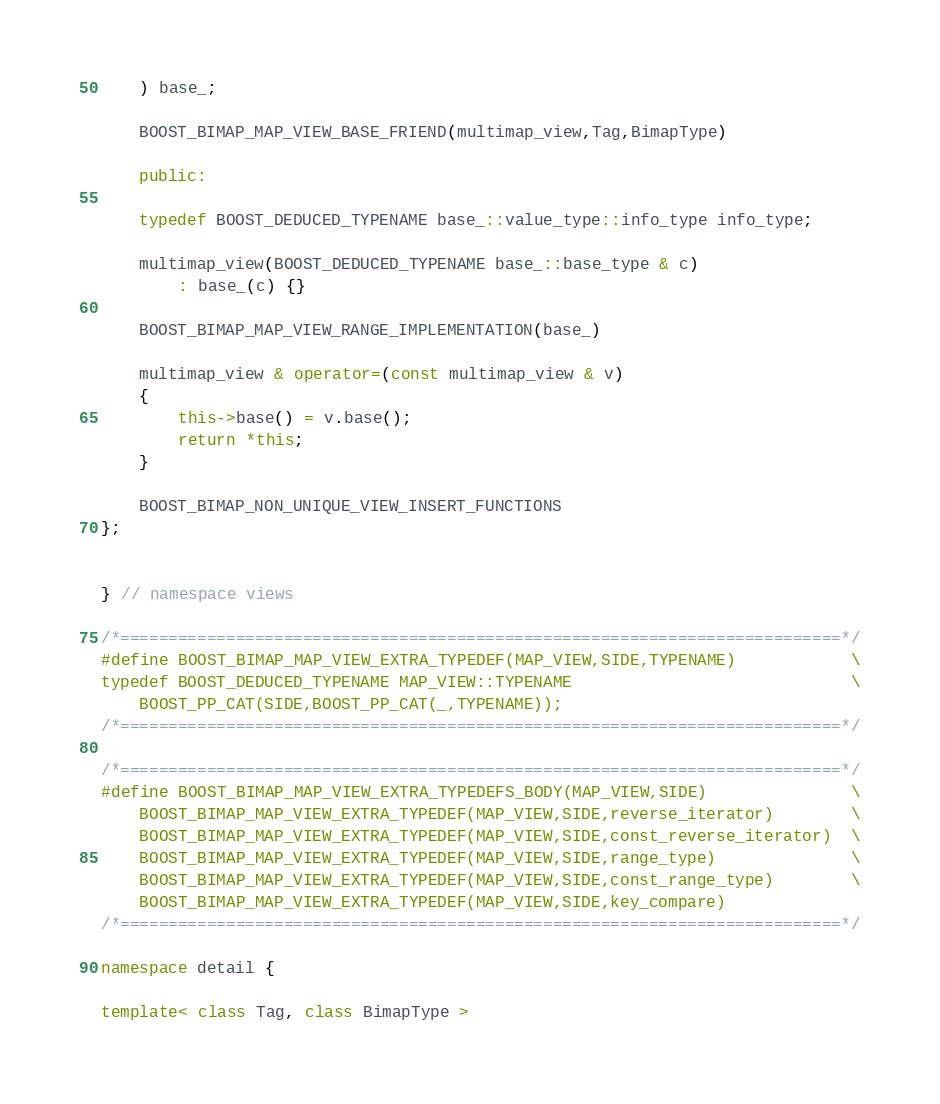Convert code to text. <code><loc_0><loc_0><loc_500><loc_500><_C++_>    ) base_;

    BOOST_BIMAP_MAP_VIEW_BASE_FRIEND(multimap_view,Tag,BimapType)

    public:

    typedef BOOST_DEDUCED_TYPENAME base_::value_type::info_type info_type;

    multimap_view(BOOST_DEDUCED_TYPENAME base_::base_type & c)
        : base_(c) {}

    BOOST_BIMAP_MAP_VIEW_RANGE_IMPLEMENTATION(base_)

    multimap_view & operator=(const multimap_view & v) 
    {
        this->base() = v.base();
        return *this;
    }

    BOOST_BIMAP_NON_UNIQUE_VIEW_INSERT_FUNCTIONS
};


} // namespace views

/*===========================================================================*/
#define BOOST_BIMAP_MAP_VIEW_EXTRA_TYPEDEF(MAP_VIEW,SIDE,TYPENAME)            \
typedef BOOST_DEDUCED_TYPENAME MAP_VIEW::TYPENAME                             \
    BOOST_PP_CAT(SIDE,BOOST_PP_CAT(_,TYPENAME));
/*===========================================================================*/

/*===========================================================================*/
#define BOOST_BIMAP_MAP_VIEW_EXTRA_TYPEDEFS_BODY(MAP_VIEW,SIDE)               \
    BOOST_BIMAP_MAP_VIEW_EXTRA_TYPEDEF(MAP_VIEW,SIDE,reverse_iterator)        \
    BOOST_BIMAP_MAP_VIEW_EXTRA_TYPEDEF(MAP_VIEW,SIDE,const_reverse_iterator)  \
    BOOST_BIMAP_MAP_VIEW_EXTRA_TYPEDEF(MAP_VIEW,SIDE,range_type)              \
    BOOST_BIMAP_MAP_VIEW_EXTRA_TYPEDEF(MAP_VIEW,SIDE,const_range_type)        \
    BOOST_BIMAP_MAP_VIEW_EXTRA_TYPEDEF(MAP_VIEW,SIDE,key_compare)
/*===========================================================================*/

namespace detail {

template< class Tag, class BimapType ></code> 